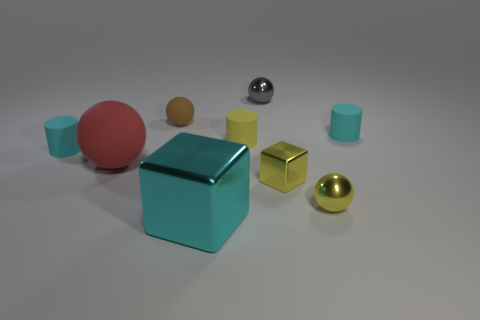What is the material of the yellow thing that is the same shape as the brown thing?
Provide a succinct answer. Metal. What material is the ball that is the same size as the cyan metal thing?
Give a very brief answer. Rubber. There is a small cyan object that is on the right side of the brown ball; is its shape the same as the small yellow metal thing behind the yellow ball?
Your answer should be very brief. No. There is a yellow matte thing that is the same size as the gray metallic sphere; what shape is it?
Your response must be concise. Cylinder. Are the small sphere that is in front of the tiny yellow matte cylinder and the small cylinder that is to the left of the large rubber object made of the same material?
Your response must be concise. No. Are there any large blocks that are behind the small shiny ball that is to the left of the small metal cube?
Offer a terse response. No. There is a big block that is made of the same material as the gray ball; what color is it?
Offer a terse response. Cyan. Is the number of tiny red matte cylinders greater than the number of things?
Provide a succinct answer. No. What number of objects are matte objects that are right of the small yellow matte cylinder or small gray shiny objects?
Your response must be concise. 2. Is there a green sphere that has the same size as the cyan metallic cube?
Ensure brevity in your answer.  No. 